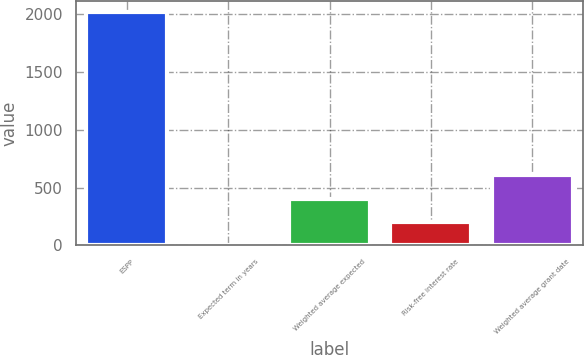Convert chart. <chart><loc_0><loc_0><loc_500><loc_500><bar_chart><fcel>ESPP<fcel>Expected term in years<fcel>Weighted average expected<fcel>Risk-free interest rate<fcel>Weighted average grant date<nl><fcel>2018<fcel>0.5<fcel>404<fcel>202.25<fcel>605.75<nl></chart> 